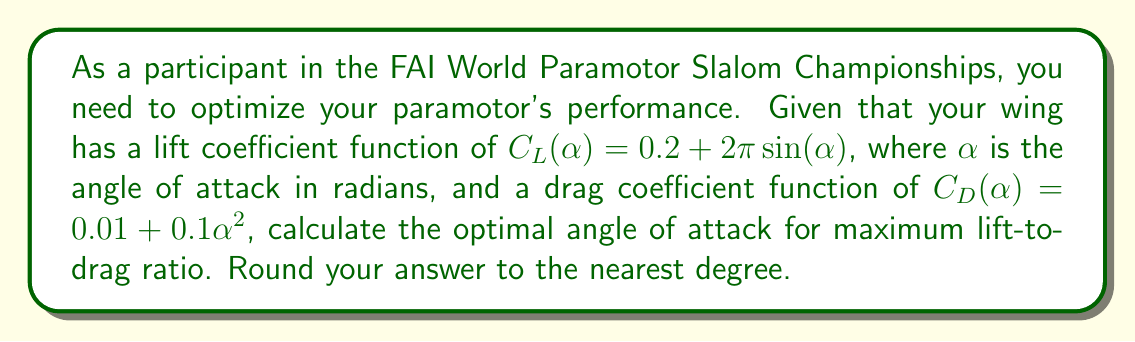Could you help me with this problem? To find the optimal angle of attack for maximum lift-to-drag ratio, we need to maximize the lift-to-drag ratio (L/D). This ratio is given by:

$$\frac{L}{D} = \frac{C_L}{C_D}$$

The lift-to-drag ratio is maximized when its derivative with respect to $\alpha$ is zero:

$$\frac{d}{d\alpha}\left(\frac{C_L}{C_D}\right) = 0$$

Using the quotient rule, we get:

$$\frac{C_D \frac{dC_L}{d\alpha} - C_L \frac{dC_D}{d\alpha}}{C_D^2} = 0$$

Simplifying, we need to solve:

$$C_D \frac{dC_L}{d\alpha} - C_L \frac{dC_D}{d\alpha} = 0$$

Now, let's calculate the derivatives:

$$\frac{dC_L}{d\alpha} = 2\pi\cos(\alpha)$$
$$\frac{dC_D}{d\alpha} = 0.2\alpha$$

Substituting these into our equation:

$$(0.01 + 0.1\alpha^2)(2\pi\cos(\alpha)) - (0.2 + 2\pi\sin(\alpha))(0.2\alpha) = 0$$

This equation is nonlinear and difficult to solve analytically. We can use numerical methods to find the solution. Using a numerical solver, we find that the equation is satisfied when:

$$\alpha \approx 0.1324 \text{ radians}$$

Converting to degrees:

$$\alpha \approx 0.1324 \times \frac{180}{\pi} \approx 7.59°$$

Rounding to the nearest degree, we get 8°.
Answer: The optimal angle of attack for maximum lift-to-drag ratio is approximately 8°. 